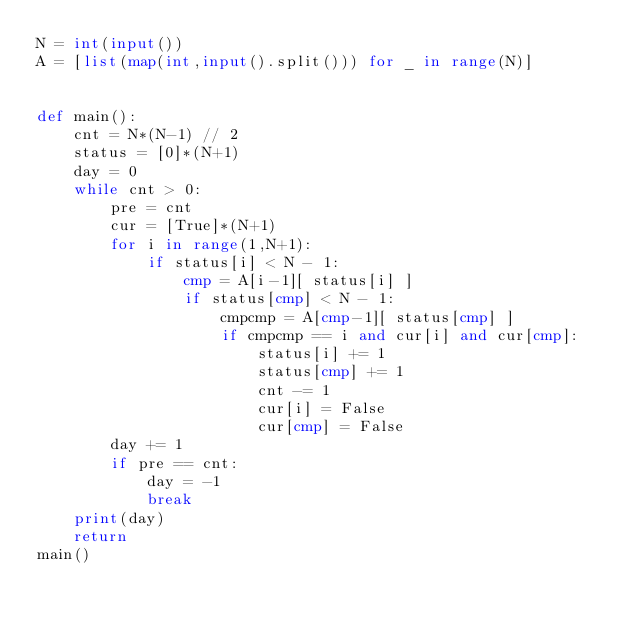<code> <loc_0><loc_0><loc_500><loc_500><_Python_>N = int(input())
A = [list(map(int,input().split())) for _ in range(N)]
    

def main():
    cnt = N*(N-1) // 2
    status = [0]*(N+1)
    day = 0
    while cnt > 0:
        pre = cnt
        cur = [True]*(N+1)
        for i in range(1,N+1):
            if status[i] < N - 1:
                cmp = A[i-1][ status[i] ]
                if status[cmp] < N - 1:
                    cmpcmp = A[cmp-1][ status[cmp] ]
                    if cmpcmp == i and cur[i] and cur[cmp]:
                        status[i] += 1
                        status[cmp] += 1
                        cnt -= 1
                        cur[i] = False
                        cur[cmp] = False
        day += 1
        if pre == cnt:
            day = -1
            break
    print(day)
    return
main()</code> 